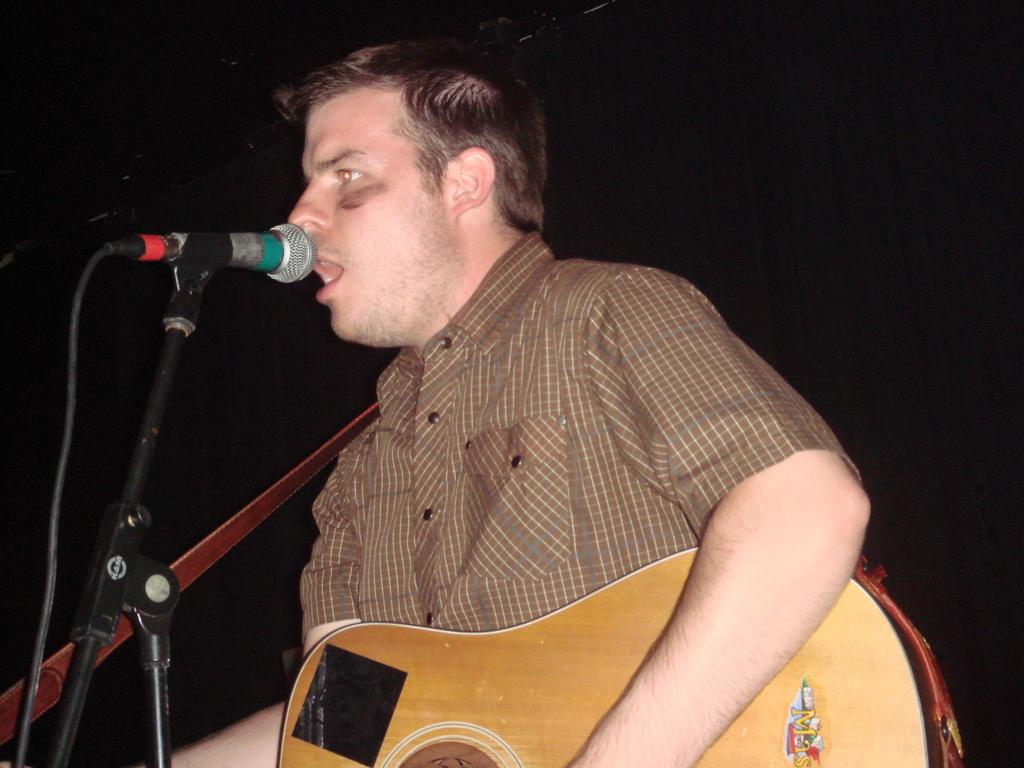What is the person in the image doing? The person is sitting and singing. What instrument is the person holding in the image? The person is holding a guitar in their hands. What is in front of the person that might be used for amplifying their voice? There is a microphone in front of the person, and there is also a microphone stand. What is the weight of the person's tongue in the image? It is not possible to determine the weight of the person's tongue from the image, as it is not visible. 